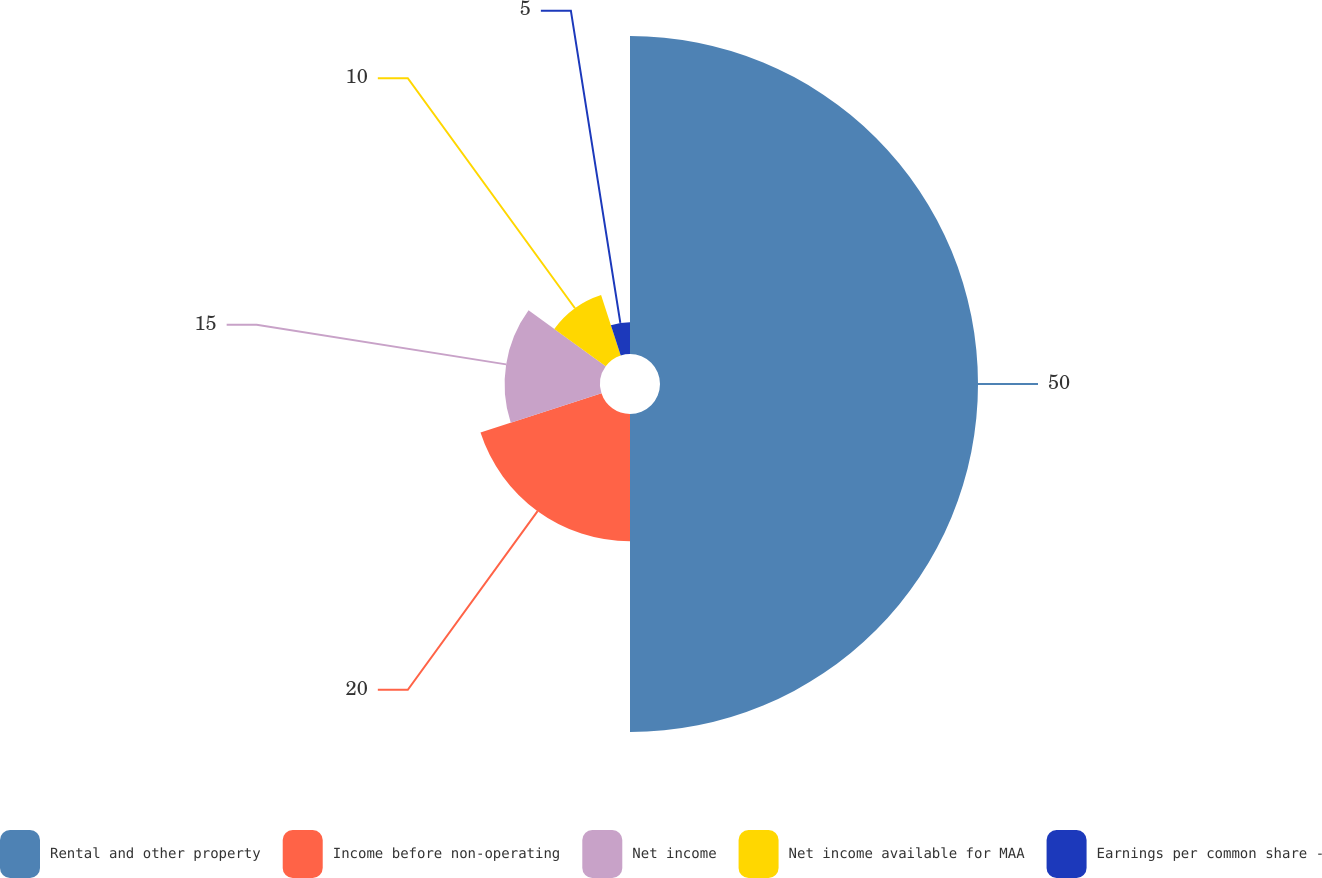Convert chart to OTSL. <chart><loc_0><loc_0><loc_500><loc_500><pie_chart><fcel>Rental and other property<fcel>Income before non-operating<fcel>Net income<fcel>Net income available for MAA<fcel>Earnings per common share -<nl><fcel>50.0%<fcel>20.0%<fcel>15.0%<fcel>10.0%<fcel>5.0%<nl></chart> 